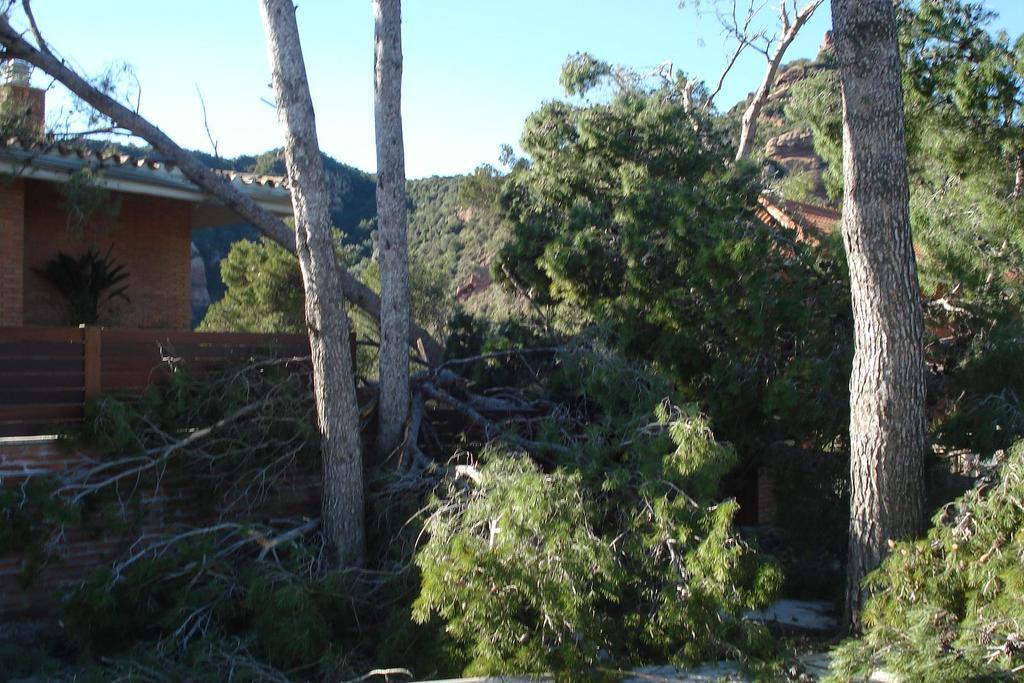In one or two sentences, can you explain what this image depicts? In this image we can see a few houses, trees and rocks, in the background we can see the sky. 